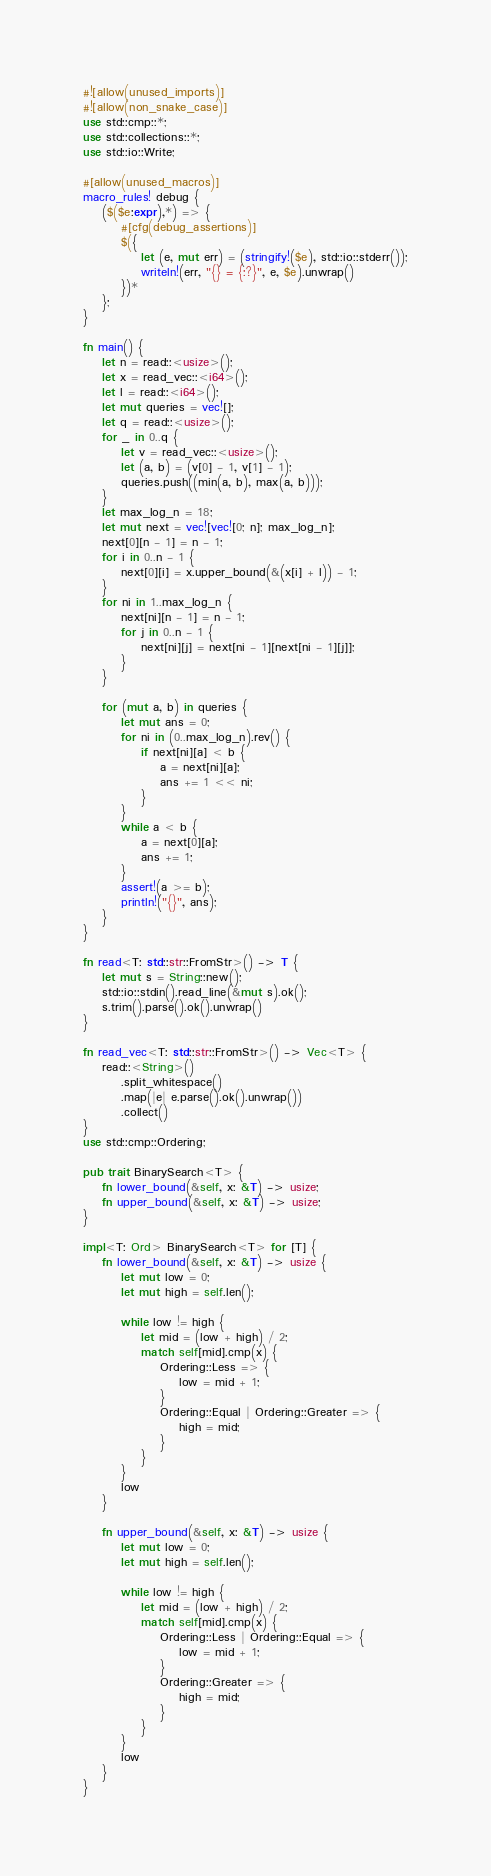<code> <loc_0><loc_0><loc_500><loc_500><_Rust_>#![allow(unused_imports)]
#![allow(non_snake_case)]
use std::cmp::*;
use std::collections::*;
use std::io::Write;

#[allow(unused_macros)]
macro_rules! debug {
    ($($e:expr),*) => {
        #[cfg(debug_assertions)]
        $({
            let (e, mut err) = (stringify!($e), std::io::stderr());
            writeln!(err, "{} = {:?}", e, $e).unwrap()
        })*
    };
}

fn main() {
    let n = read::<usize>();
    let x = read_vec::<i64>();
    let l = read::<i64>();
    let mut queries = vec![];
    let q = read::<usize>();
    for _ in 0..q {
        let v = read_vec::<usize>();
        let (a, b) = (v[0] - 1, v[1] - 1);
        queries.push((min(a, b), max(a, b)));
    }
    let max_log_n = 18;
    let mut next = vec![vec![0; n]; max_log_n];
    next[0][n - 1] = n - 1;
    for i in 0..n - 1 {
        next[0][i] = x.upper_bound(&(x[i] + l)) - 1;
    }
    for ni in 1..max_log_n {
        next[ni][n - 1] = n - 1;
        for j in 0..n - 1 {
            next[ni][j] = next[ni - 1][next[ni - 1][j]];
        }
    }

    for (mut a, b) in queries {
        let mut ans = 0;
        for ni in (0..max_log_n).rev() {
            if next[ni][a] < b {
                a = next[ni][a];
                ans += 1 << ni;
            }
        }
        while a < b {
            a = next[0][a];
            ans += 1;
        }
        assert!(a >= b);
        println!("{}", ans);
    }
}

fn read<T: std::str::FromStr>() -> T {
    let mut s = String::new();
    std::io::stdin().read_line(&mut s).ok();
    s.trim().parse().ok().unwrap()
}

fn read_vec<T: std::str::FromStr>() -> Vec<T> {
    read::<String>()
        .split_whitespace()
        .map(|e| e.parse().ok().unwrap())
        .collect()
}
use std::cmp::Ordering;

pub trait BinarySearch<T> {
    fn lower_bound(&self, x: &T) -> usize;
    fn upper_bound(&self, x: &T) -> usize;
}

impl<T: Ord> BinarySearch<T> for [T] {
    fn lower_bound(&self, x: &T) -> usize {
        let mut low = 0;
        let mut high = self.len();

        while low != high {
            let mid = (low + high) / 2;
            match self[mid].cmp(x) {
                Ordering::Less => {
                    low = mid + 1;
                }
                Ordering::Equal | Ordering::Greater => {
                    high = mid;
                }
            }
        }
        low
    }

    fn upper_bound(&self, x: &T) -> usize {
        let mut low = 0;
        let mut high = self.len();

        while low != high {
            let mid = (low + high) / 2;
            match self[mid].cmp(x) {
                Ordering::Less | Ordering::Equal => {
                    low = mid + 1;
                }
                Ordering::Greater => {
                    high = mid;
                }
            }
        }
        low
    }
}
</code> 